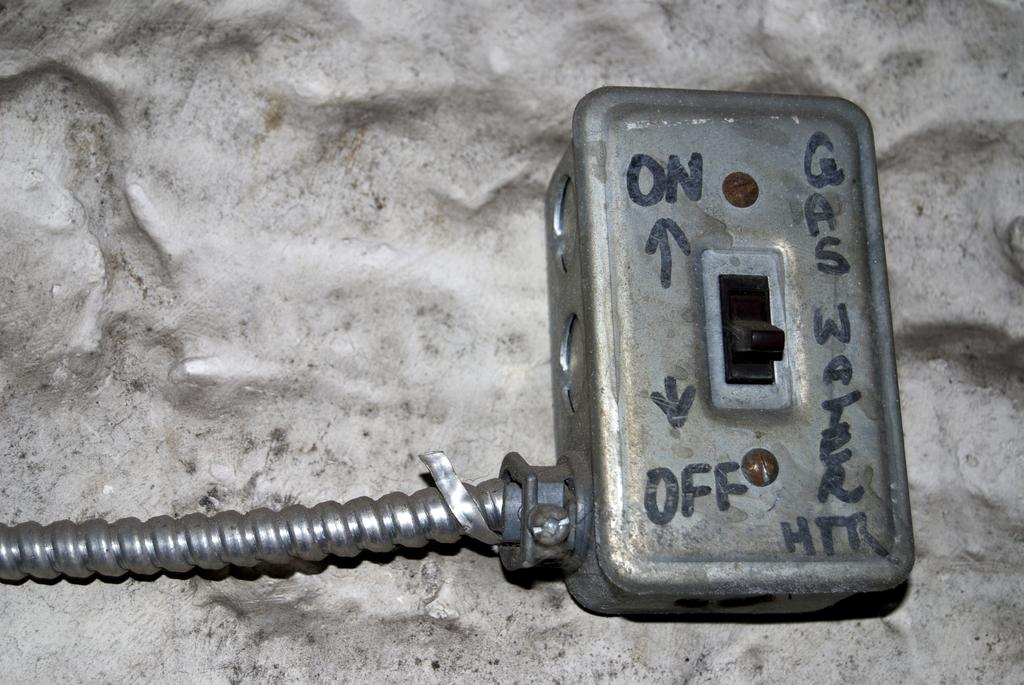<image>
Present a compact description of the photo's key features. an on and off switch to a gas heater 